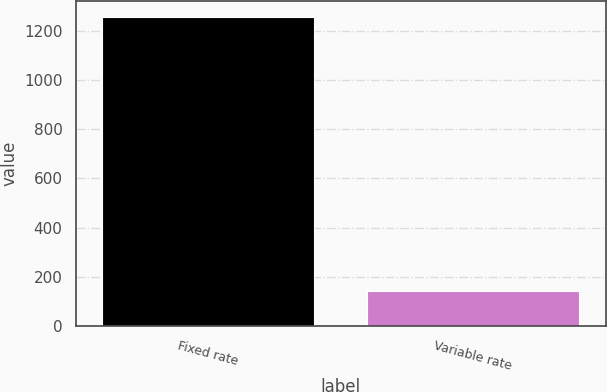Convert chart. <chart><loc_0><loc_0><loc_500><loc_500><bar_chart><fcel>Fixed rate<fcel>Variable rate<nl><fcel>1258.6<fcel>143.3<nl></chart> 